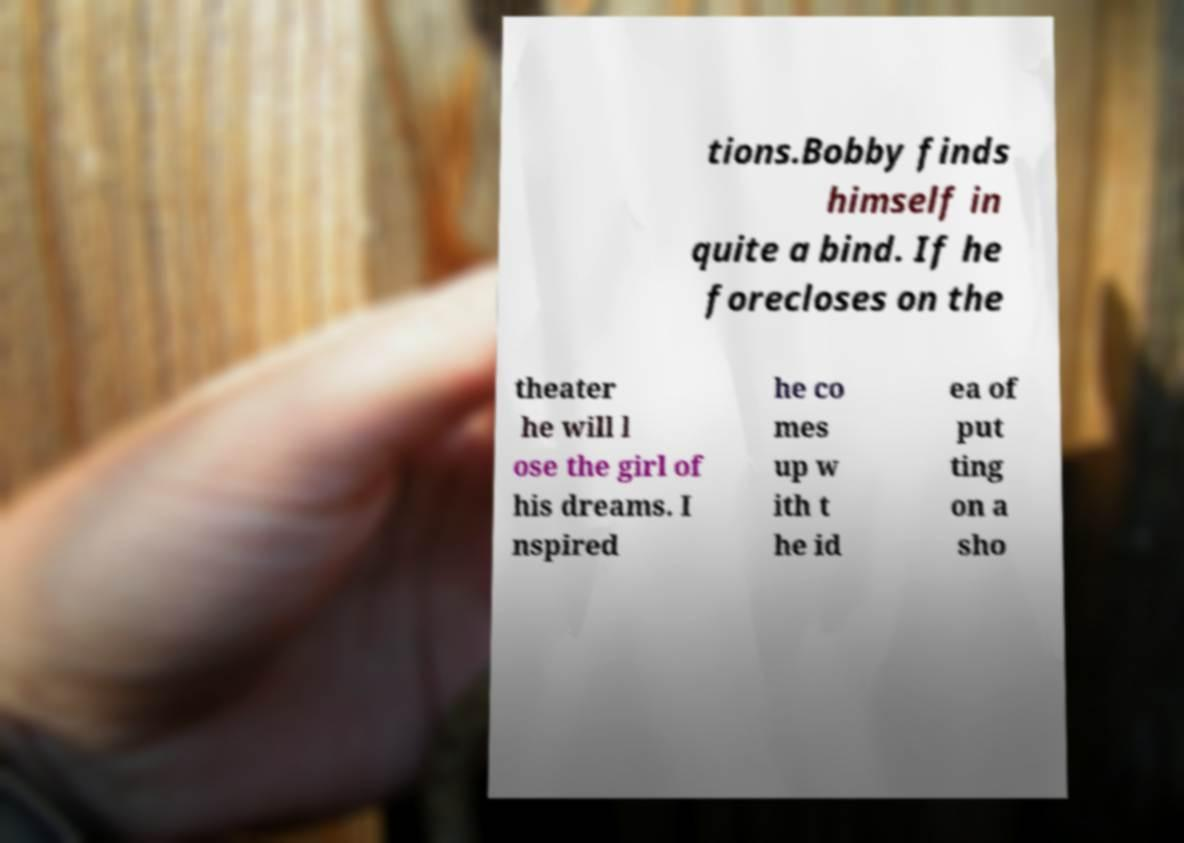Please identify and transcribe the text found in this image. tions.Bobby finds himself in quite a bind. If he forecloses on the theater he will l ose the girl of his dreams. I nspired he co mes up w ith t he id ea of put ting on a sho 